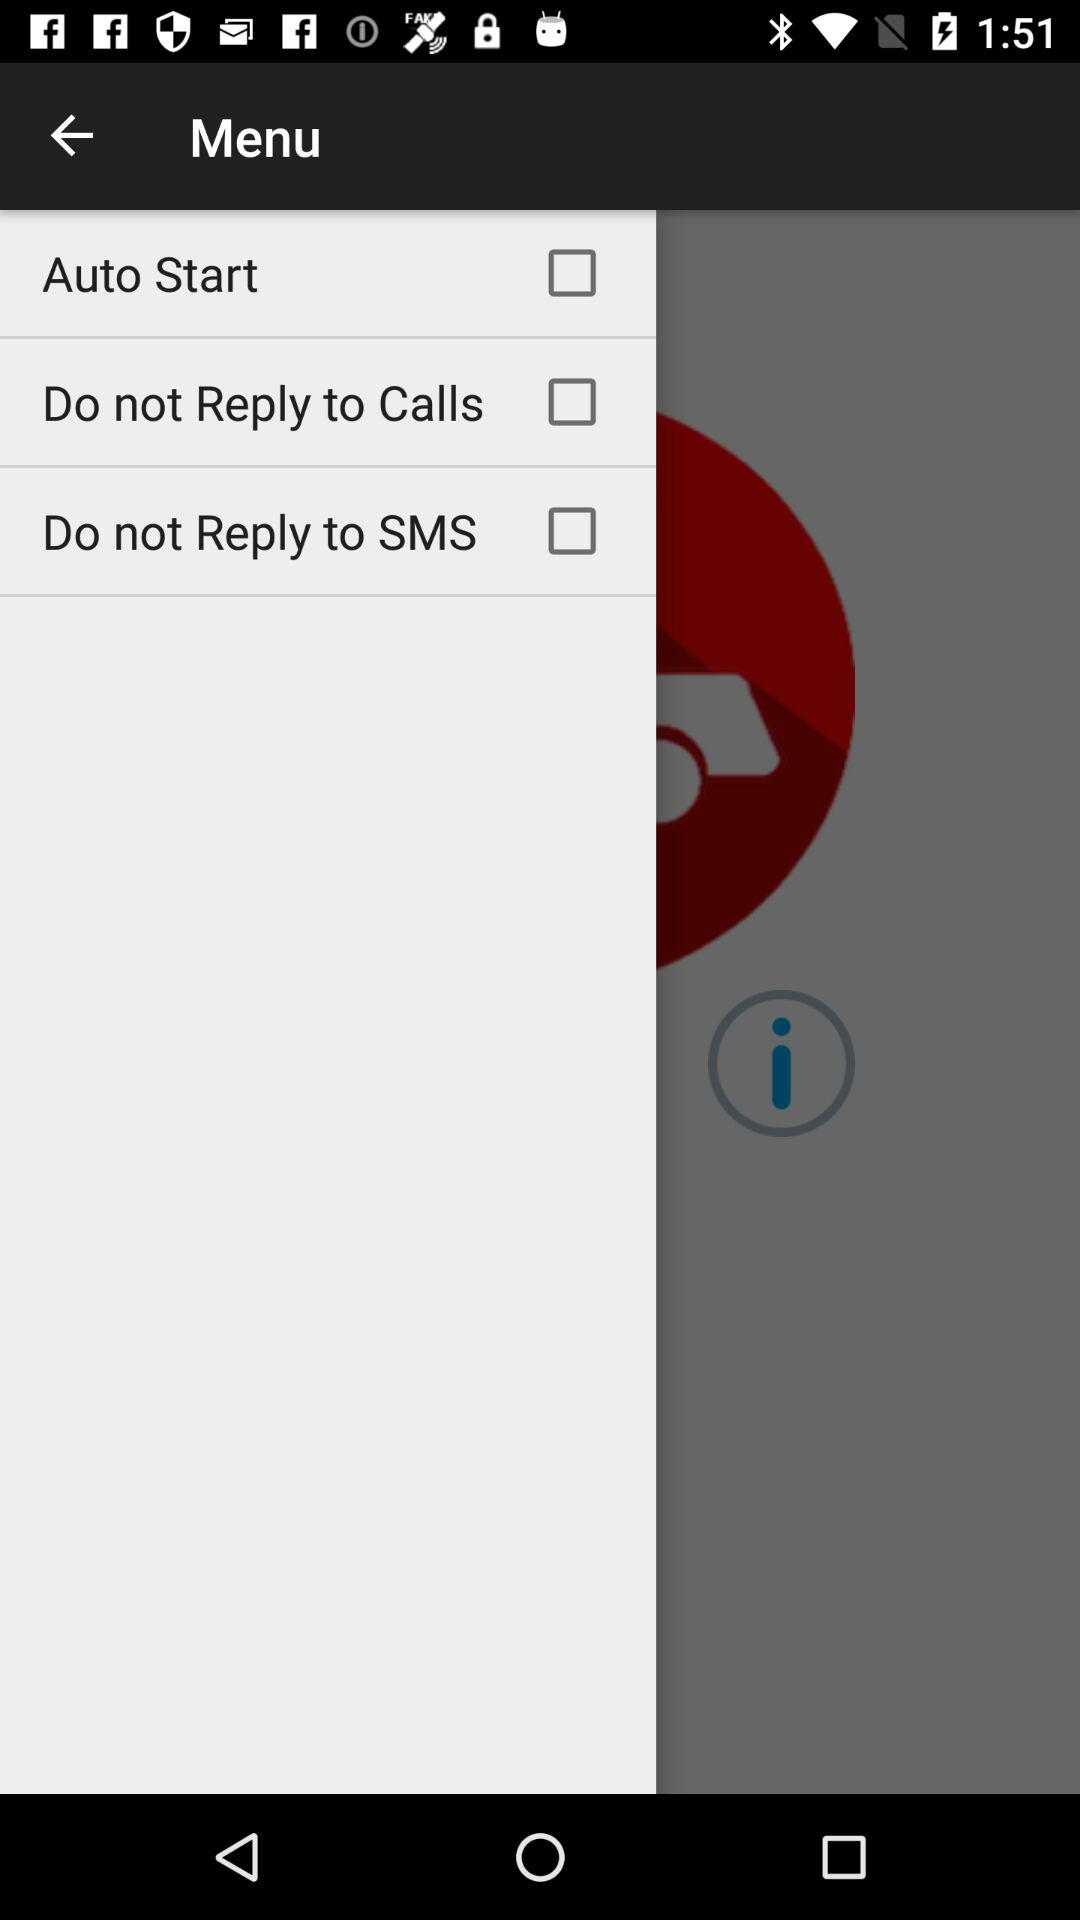What is the status of the "Auto Start"? The status is "off". 